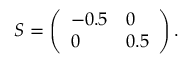<formula> <loc_0><loc_0><loc_500><loc_500>\begin{array} { r } { S = \left ( \begin{array} { l l } { - 0 . 5 } & { 0 } \\ { 0 } & { 0 . 5 } \end{array} \right ) . } \end{array}</formula> 